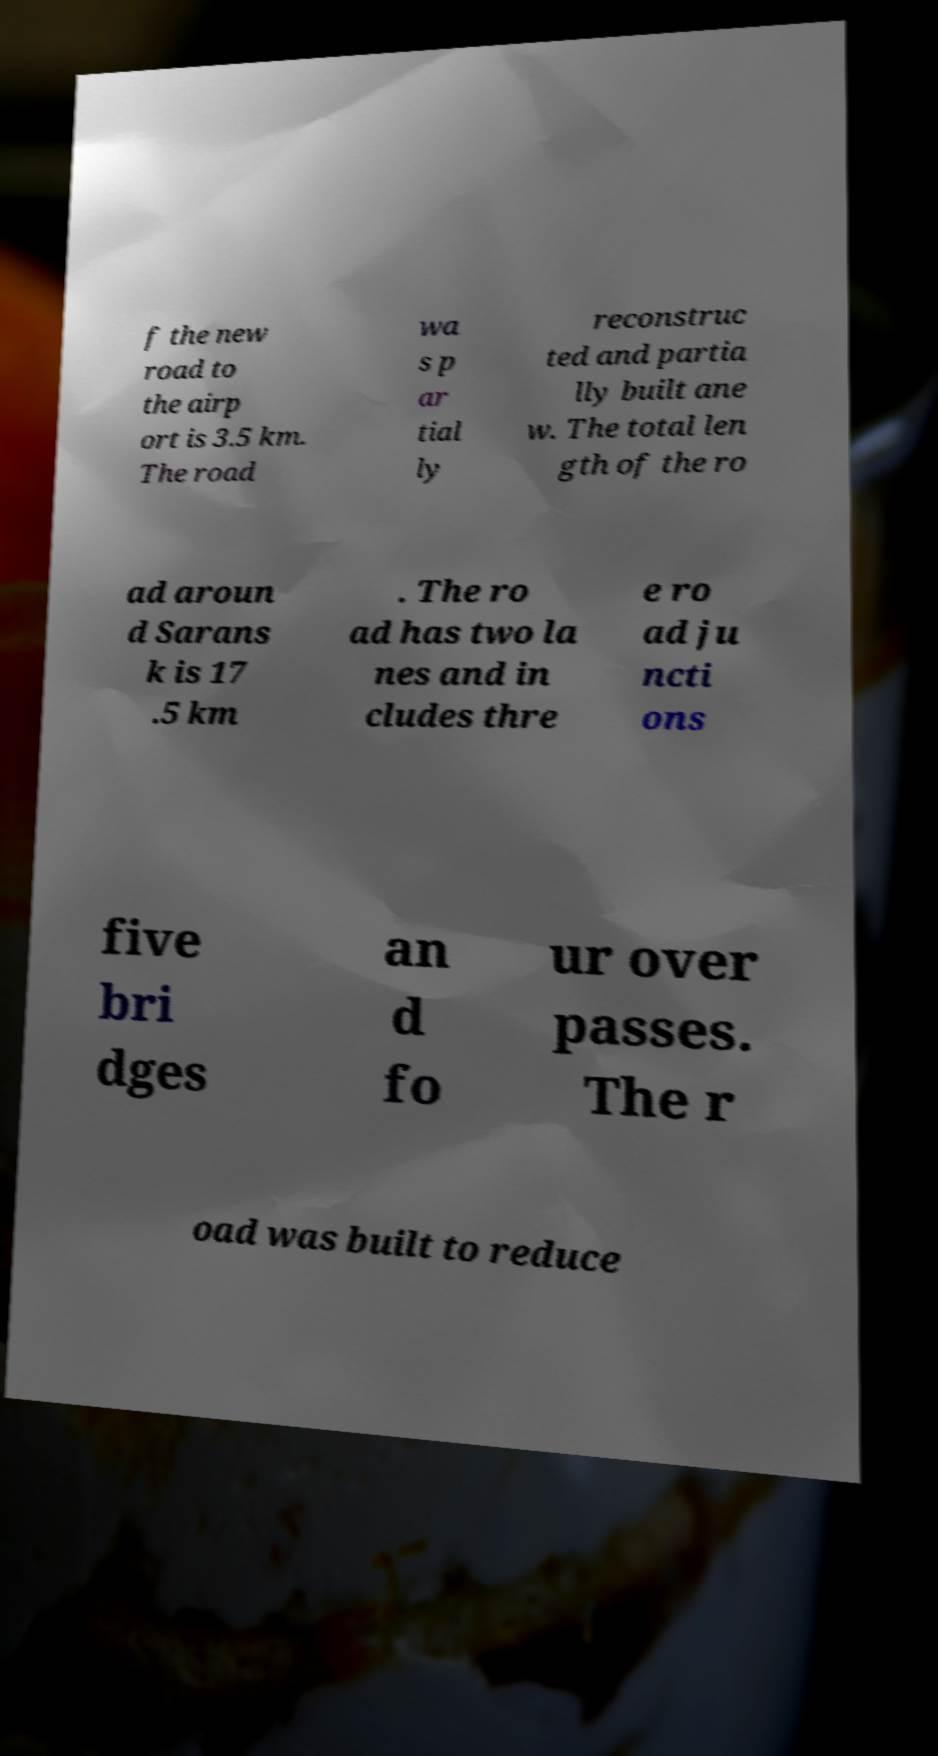For documentation purposes, I need the text within this image transcribed. Could you provide that? f the new road to the airp ort is 3.5 km. The road wa s p ar tial ly reconstruc ted and partia lly built ane w. The total len gth of the ro ad aroun d Sarans k is 17 .5 km . The ro ad has two la nes and in cludes thre e ro ad ju ncti ons five bri dges an d fo ur over passes. The r oad was built to reduce 